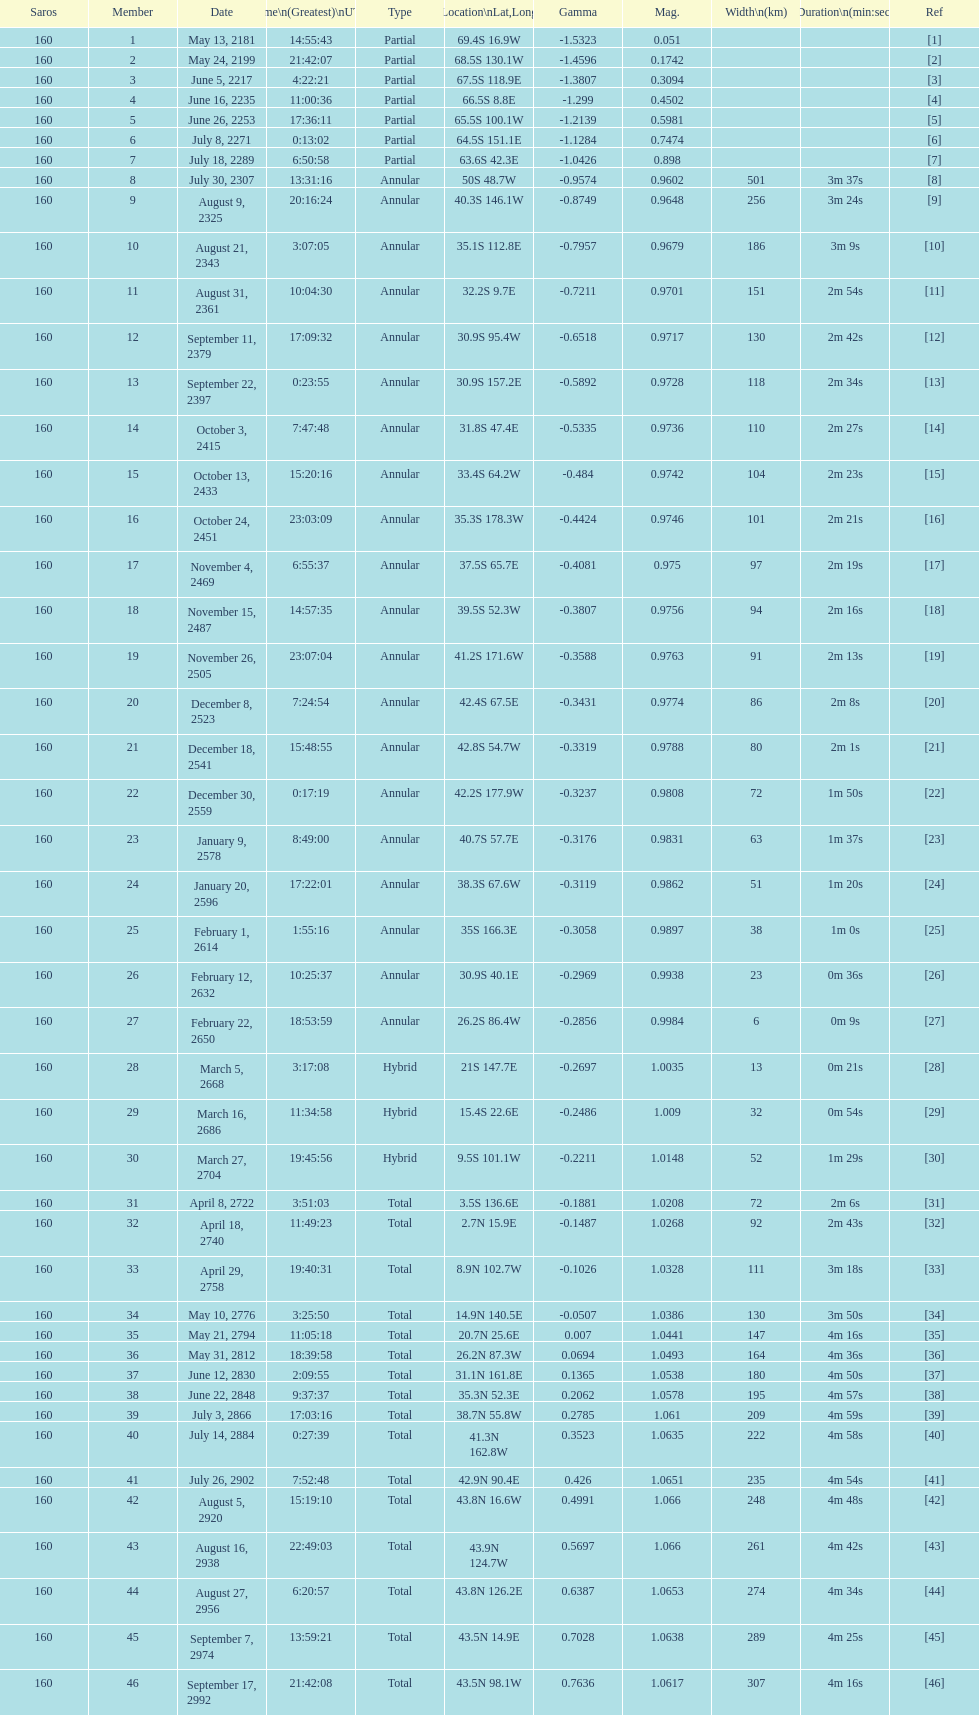How many solar saros events lasted longer than 4 minutes? 12. 